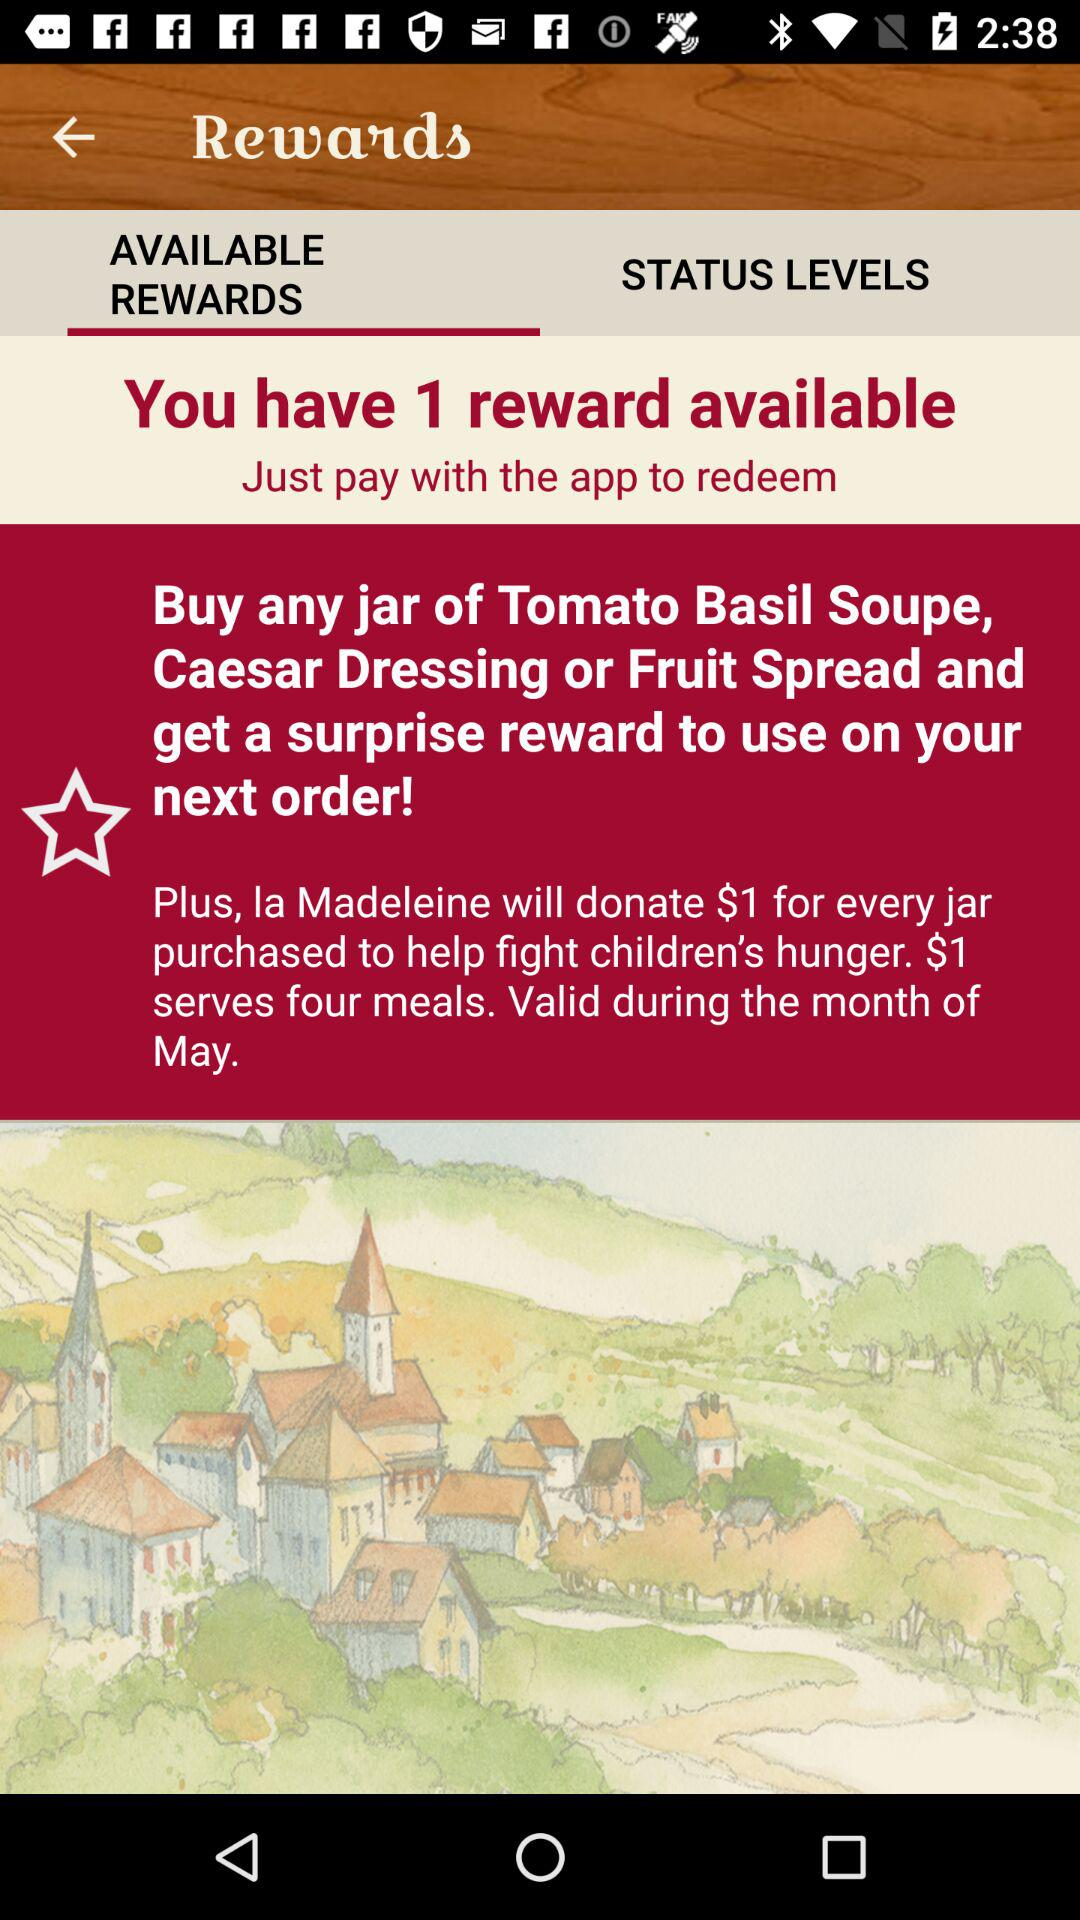How much does la Madeleine donate for every jar purchased?
Answer the question using a single word or phrase. $1 